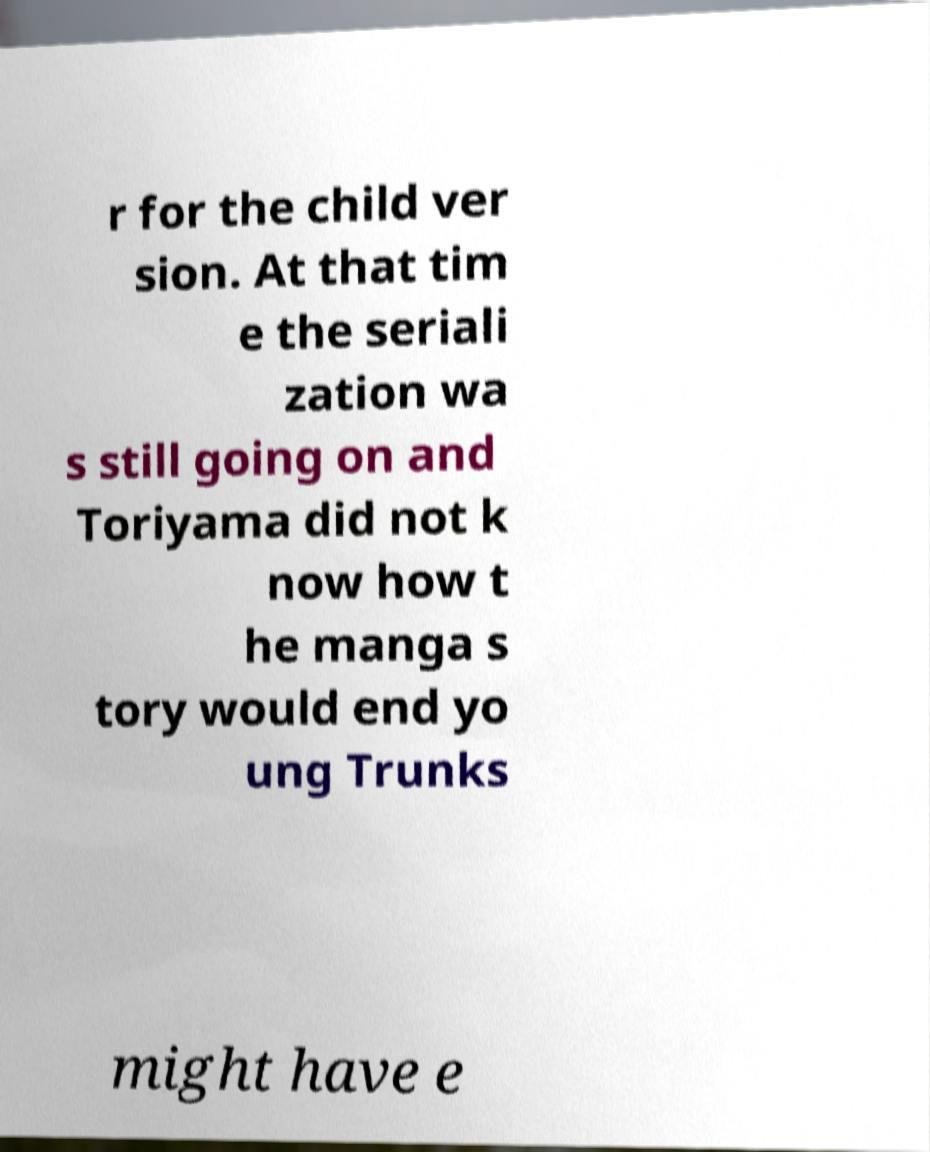Can you accurately transcribe the text from the provided image for me? r for the child ver sion. At that tim e the seriali zation wa s still going on and Toriyama did not k now how t he manga s tory would end yo ung Trunks might have e 